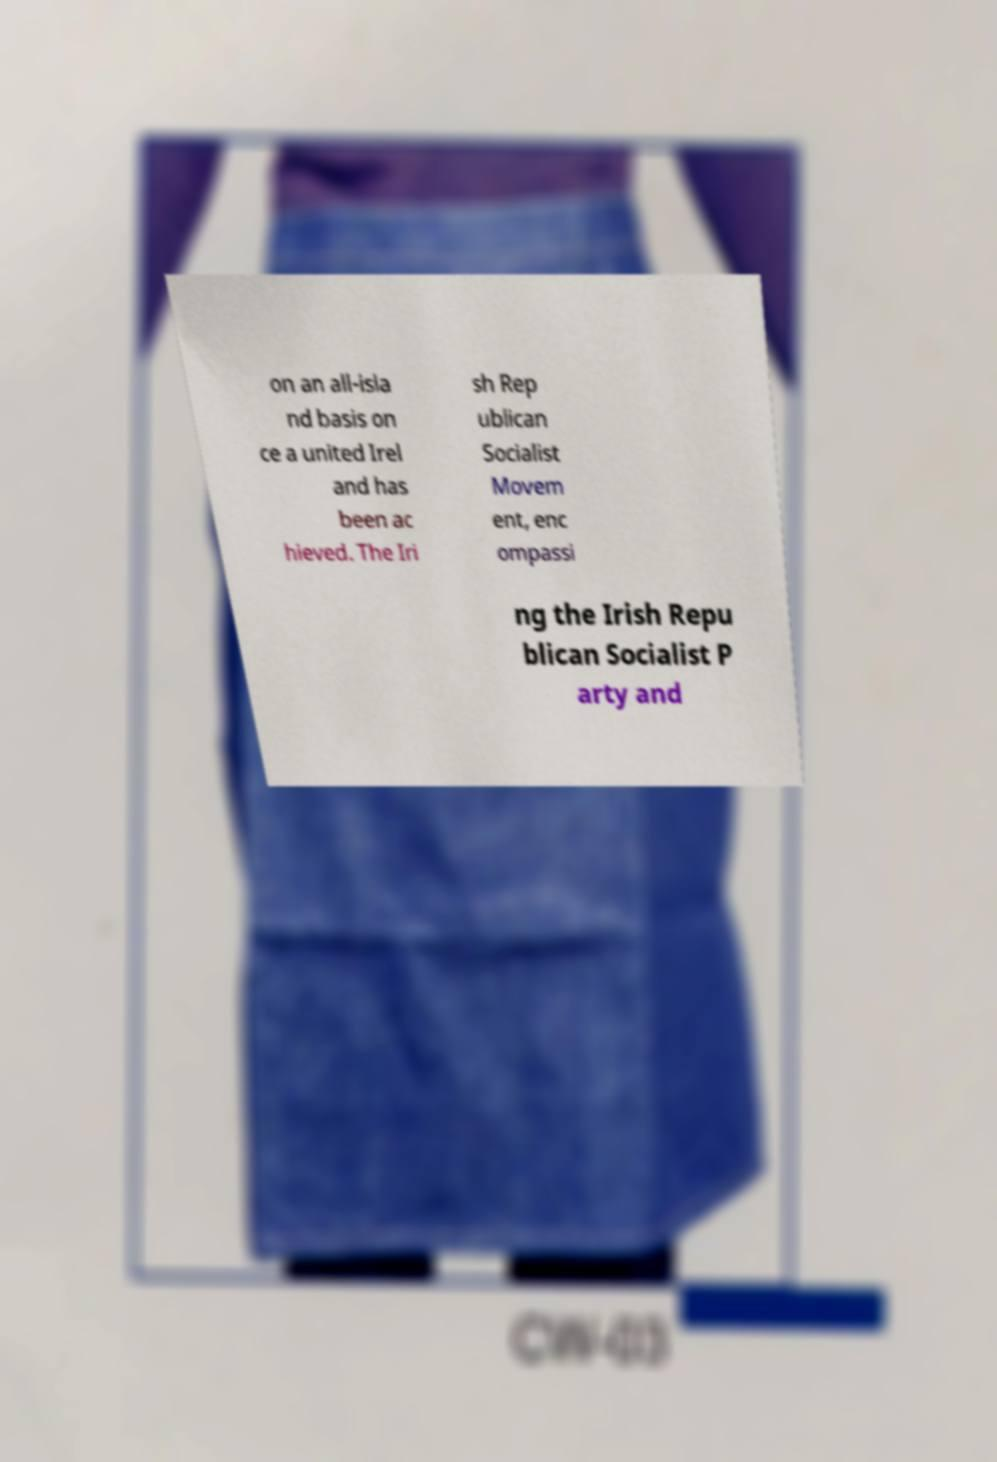Could you assist in decoding the text presented in this image and type it out clearly? on an all-isla nd basis on ce a united Irel and has been ac hieved. The Iri sh Rep ublican Socialist Movem ent, enc ompassi ng the Irish Repu blican Socialist P arty and 